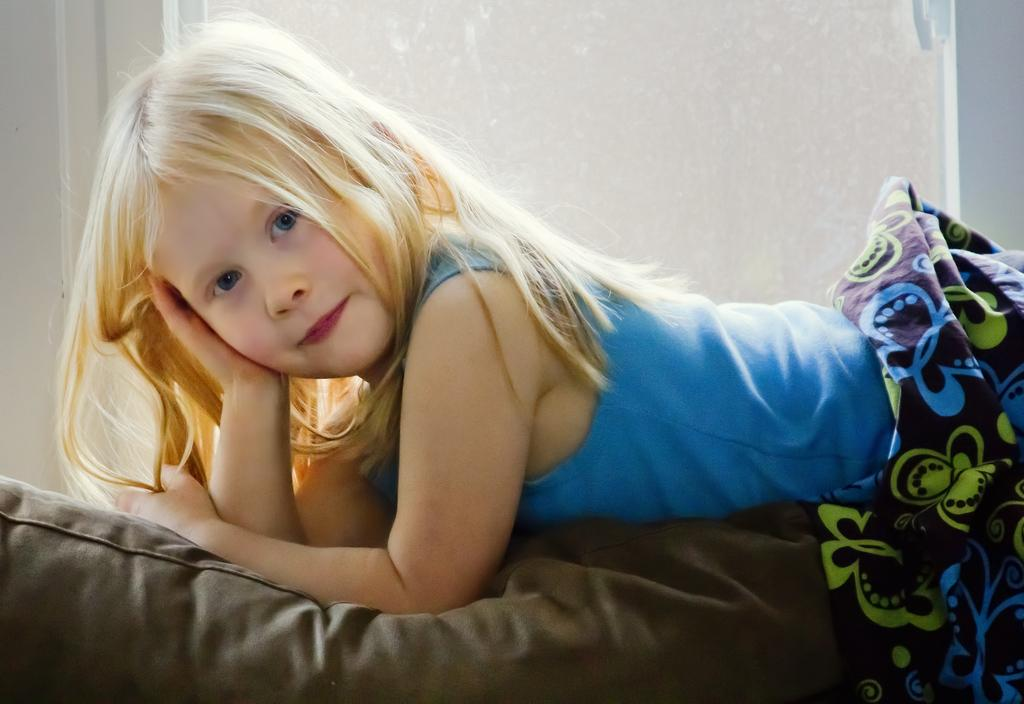What is the child doing in the image? The child is on the bed in the image. What type of material can be seen in the image? There is a cloth visible in the image. What can be seen in the background of the image? There is a wall visible in the background of the image. What type of blade is being used by the child in the image? There is no blade present in the image; the child is simply on the bed. 